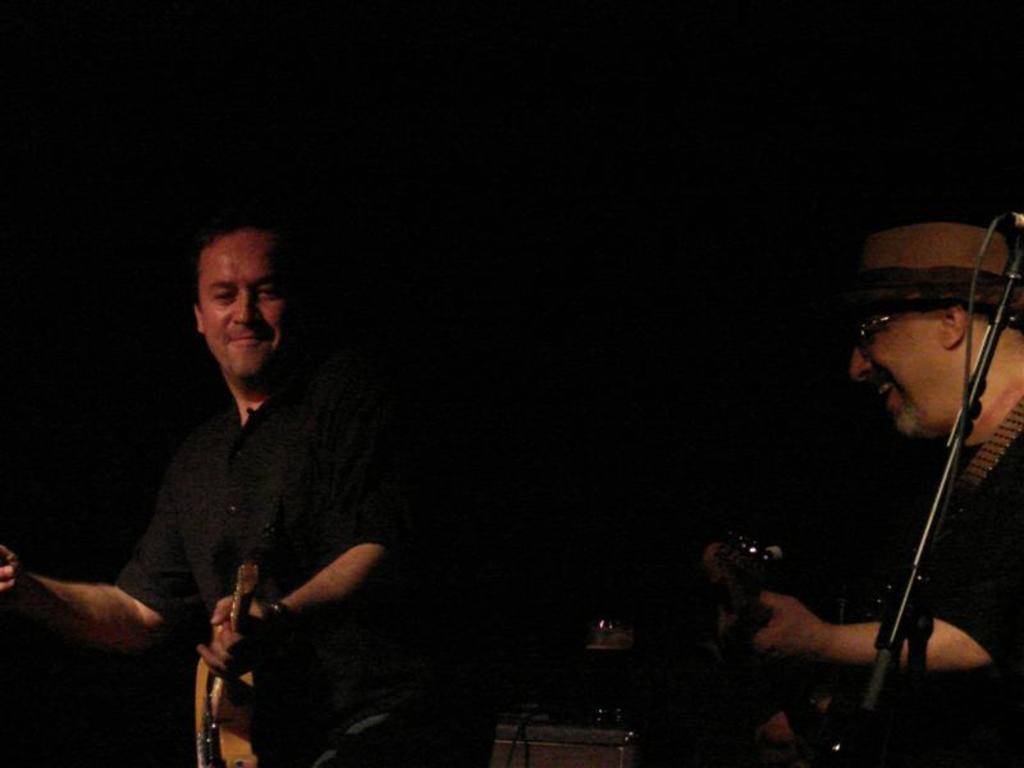In one or two sentences, can you explain what this image depicts? There are two people. They are playing a musical instruments. 